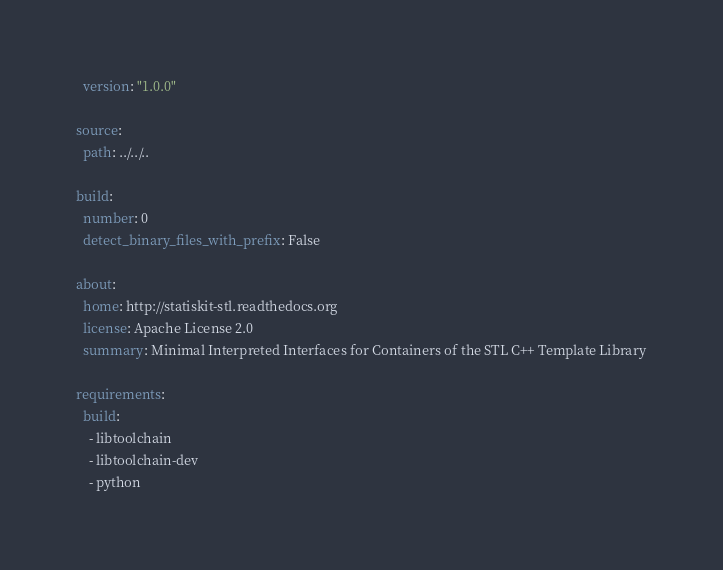Convert code to text. <code><loc_0><loc_0><loc_500><loc_500><_YAML_>  version: "1.0.0"

source:
  path: ../../..

build:
  number: 0
  detect_binary_files_with_prefix: False
  
about:
  home: http://statiskit-stl.readthedocs.org
  license: Apache License 2.0
  summary: Minimal Interpreted Interfaces for Containers of the STL C++ Template Library

requirements:
  build:
    - libtoolchain
    - libtoolchain-dev
    - python</code> 